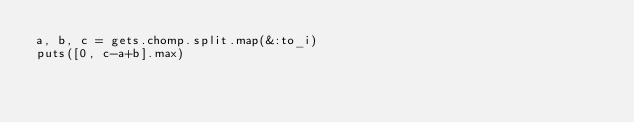<code> <loc_0><loc_0><loc_500><loc_500><_Ruby_>a, b, c = gets.chomp.split.map(&:to_i)
puts([0, c-a+b].max)</code> 